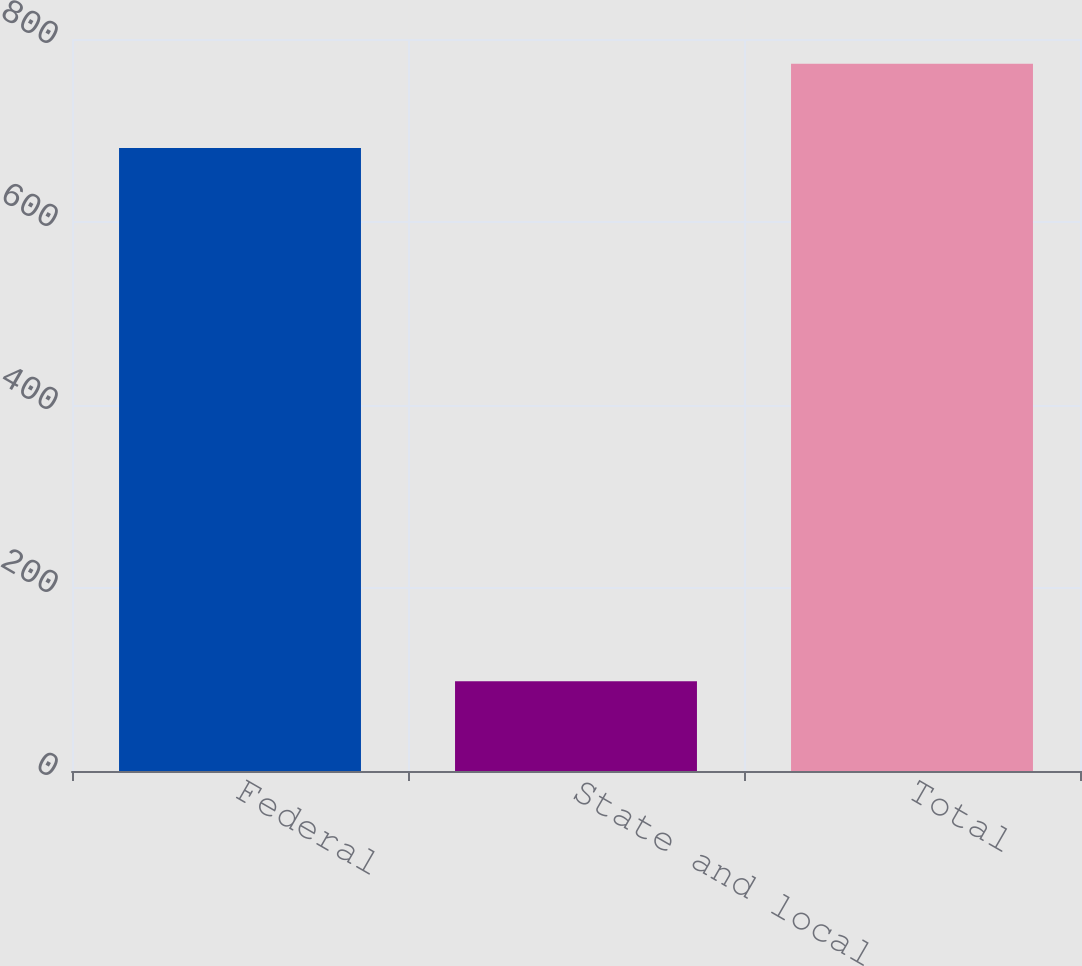Convert chart to OTSL. <chart><loc_0><loc_0><loc_500><loc_500><bar_chart><fcel>Federal<fcel>State and local<fcel>Total<nl><fcel>681<fcel>98<fcel>773<nl></chart> 